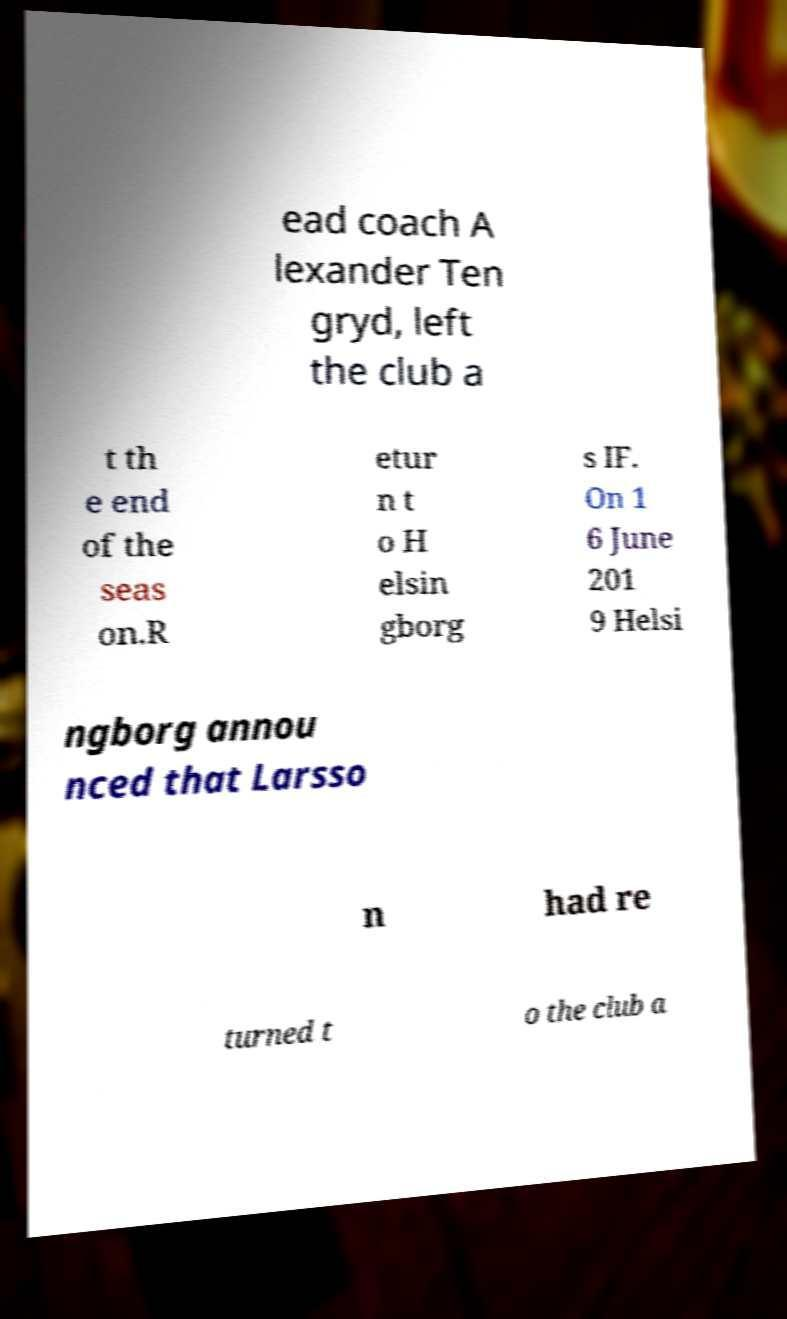I need the written content from this picture converted into text. Can you do that? ead coach A lexander Ten gryd, left the club a t th e end of the seas on.R etur n t o H elsin gborg s IF. On 1 6 June 201 9 Helsi ngborg annou nced that Larsso n had re turned t o the club a 